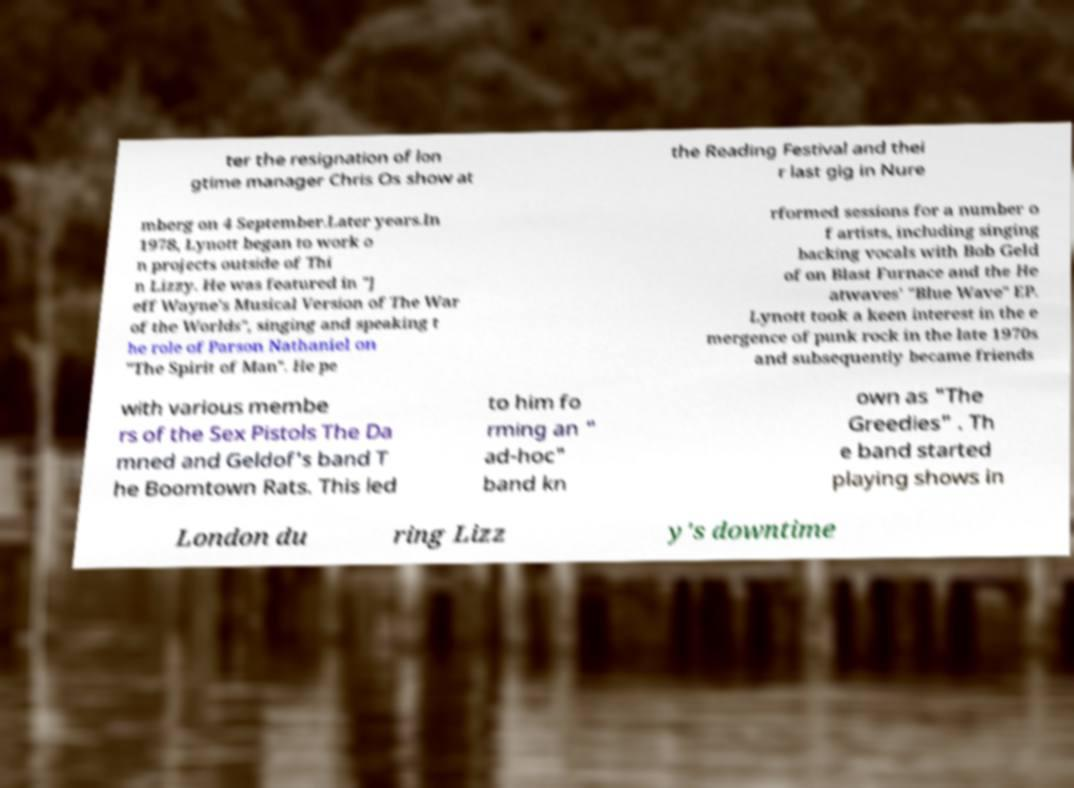Could you assist in decoding the text presented in this image and type it out clearly? ter the resignation of lon gtime manager Chris Os show at the Reading Festival and thei r last gig in Nure mberg on 4 September.Later years.In 1978, Lynott began to work o n projects outside of Thi n Lizzy. He was featured in "J eff Wayne's Musical Version of The War of the Worlds", singing and speaking t he role of Parson Nathaniel on "The Spirit of Man". He pe rformed sessions for a number o f artists, including singing backing vocals with Bob Geld of on Blast Furnace and the He atwaves' "Blue Wave" EP. Lynott took a keen interest in the e mergence of punk rock in the late 1970s and subsequently became friends with various membe rs of the Sex Pistols The Da mned and Geldof's band T he Boomtown Rats. This led to him fo rming an " ad-hoc" band kn own as "The Greedies" . Th e band started playing shows in London du ring Lizz y's downtime 